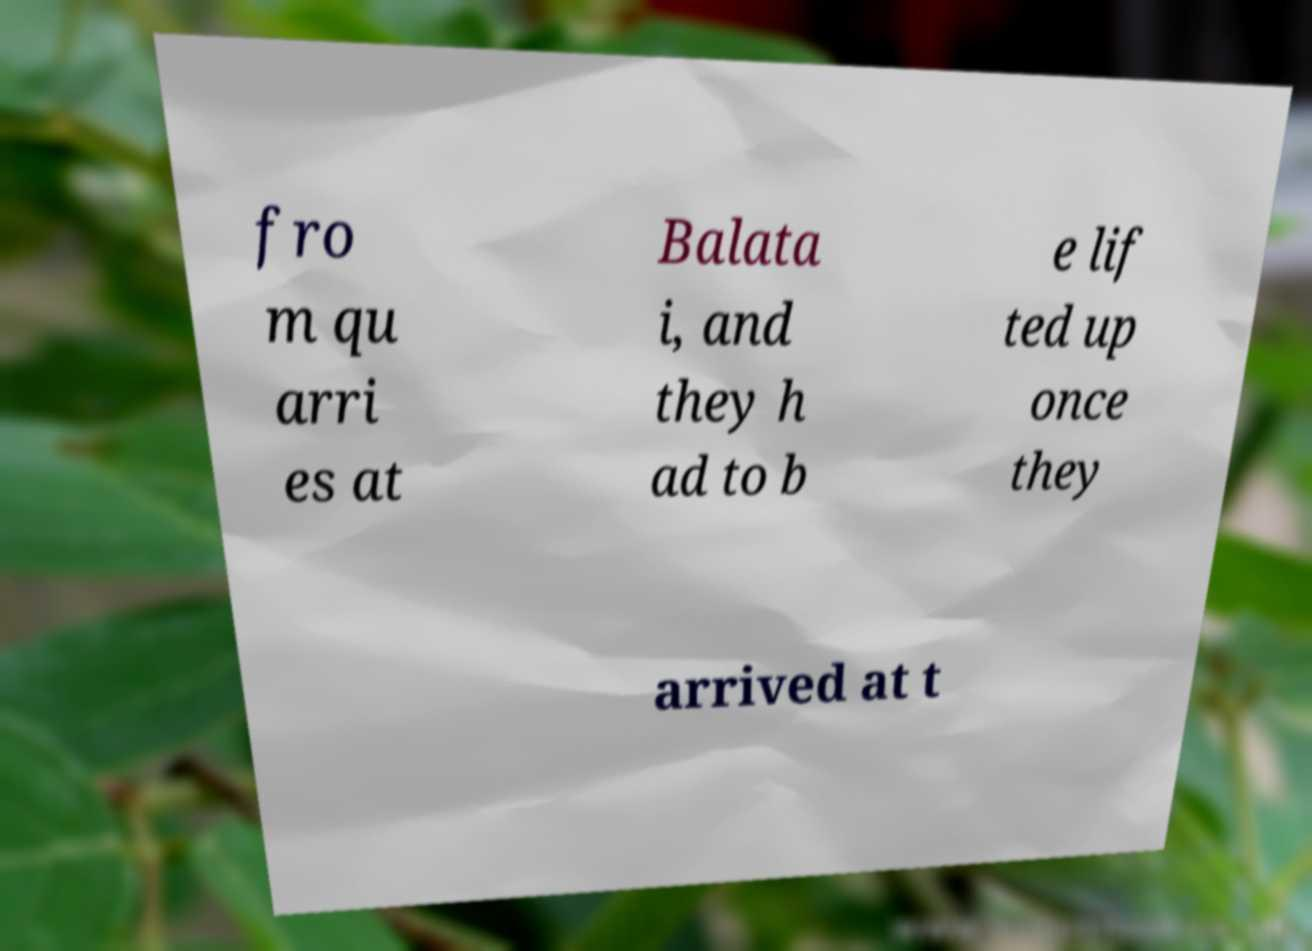Could you extract and type out the text from this image? fro m qu arri es at Balata i, and they h ad to b e lif ted up once they arrived at t 